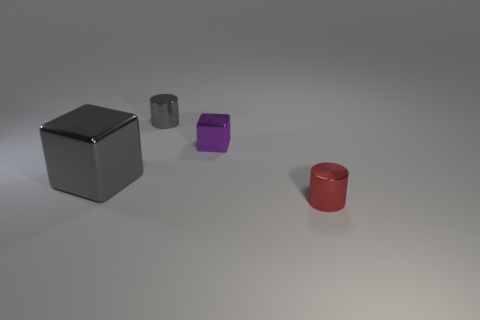Is the number of small metallic things to the left of the big gray metal object the same as the number of big gray metal cubes? no 